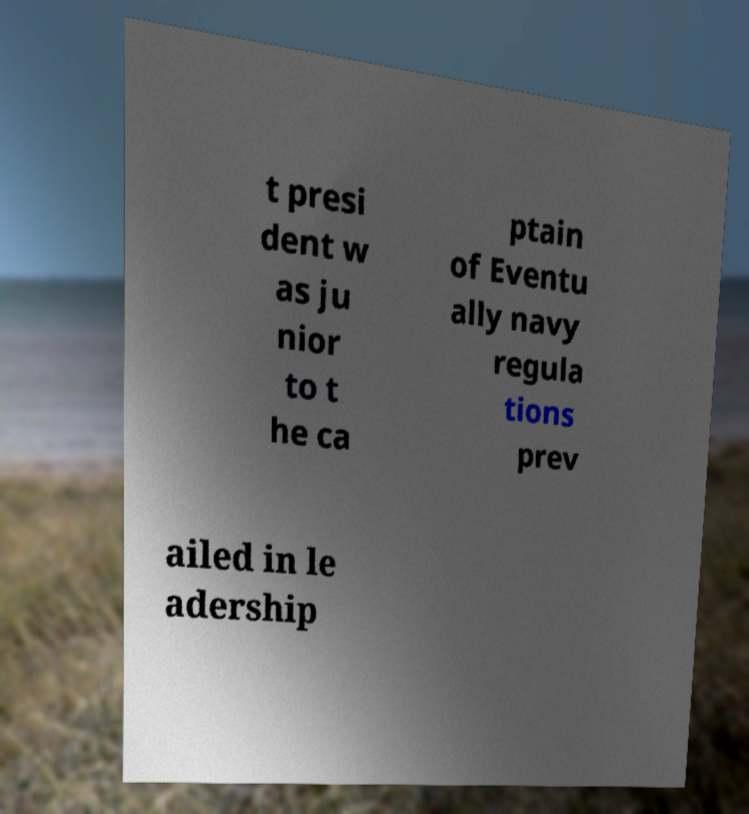What messages or text are displayed in this image? I need them in a readable, typed format. t presi dent w as ju nior to t he ca ptain of Eventu ally navy regula tions prev ailed in le adership 